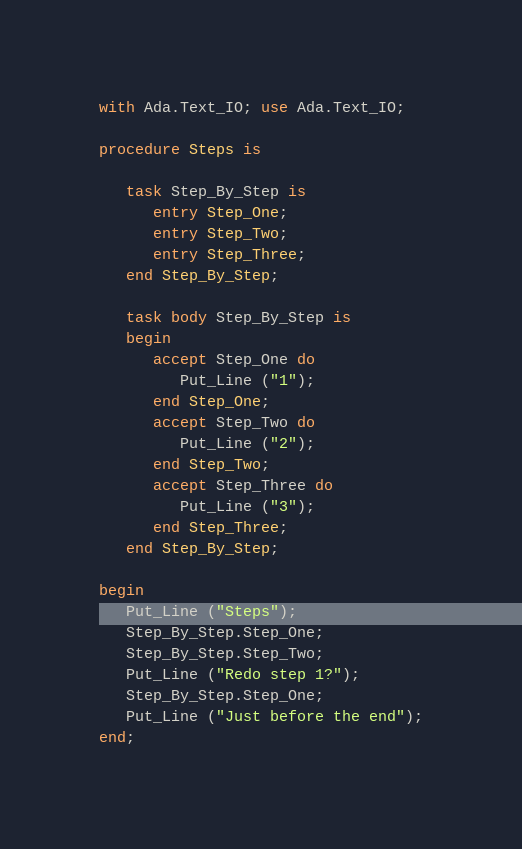Convert code to text. <code><loc_0><loc_0><loc_500><loc_500><_Ada_>with Ada.Text_IO; use Ada.Text_IO;

procedure Steps is
   
   task Step_By_Step is
      entry Step_One;
      entry Step_Two;
      entry Step_Three;
   end Step_By_Step;
   
   task body Step_By_Step is
   begin
      accept Step_One do
         Put_Line ("1");
      end Step_One;
      accept Step_Two do
         Put_Line ("2");
      end Step_Two;
      accept Step_Three do
         Put_Line ("3");
      end Step_Three;
   end Step_By_Step;
   
begin
   Put_Line ("Steps");
   Step_By_Step.Step_One;
   Step_By_Step.Step_Two;
   Put_Line ("Redo step 1?");
   Step_By_Step.Step_One;
   Put_Line ("Just before the end");
end;
</code> 